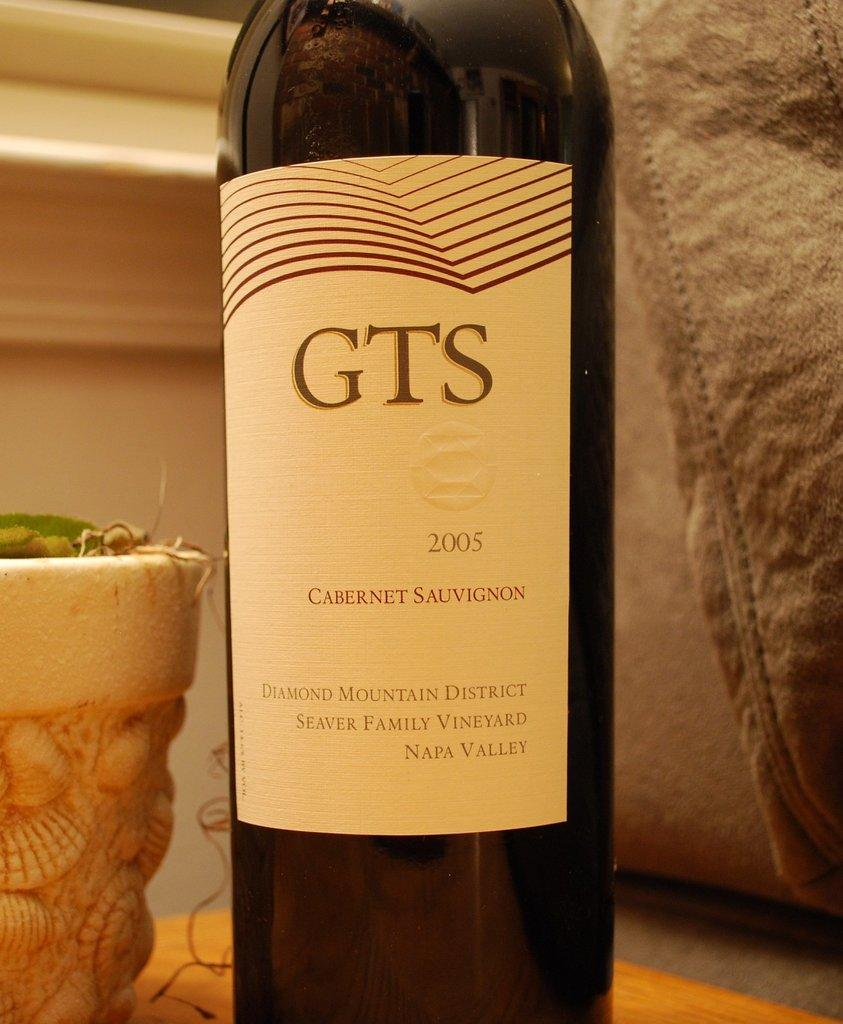<image>
Write a terse but informative summary of the picture. A bottle of GTS 2005 Cabernet Sauvignon from the Diamond Mountain District. 